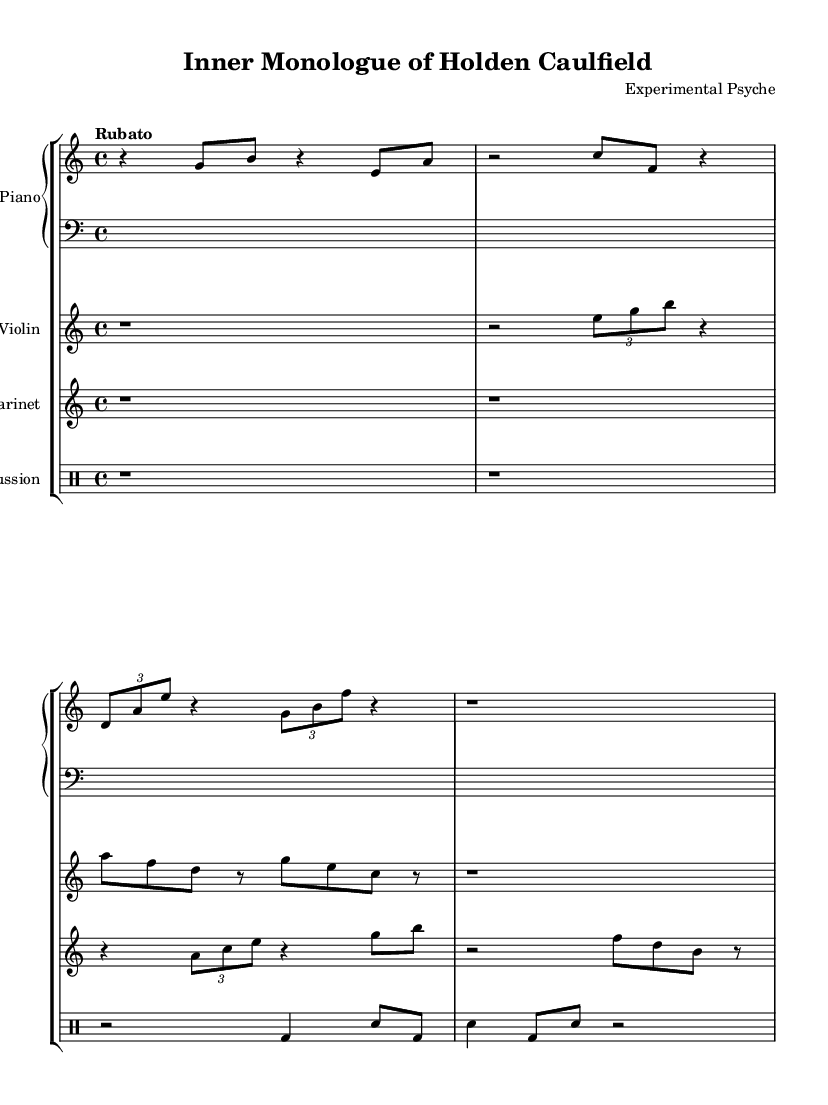What is the time signature of this music? The time signature is indicated at the beginning of the score, represented as "4/4". This means there are four beats in each measure, and the quarter note gets one beat.
Answer: 4/4 What is the tempo marking for the piece? The tempo is indicated as "Rubato", which signifies a flexible tempo. This allows the performer to stretch and compress the rhythm for expressive purposes.
Answer: Rubato What instruments are included in this composition? The instruments are listed as Piano, Violin, Clarinet, and Percussion. Each instrument has its own staff in the score, indicating they play simultaneously.
Answer: Piano, Violin, Clarinet, Percussion How many measures are present in the piano part? By counting the distinct groupings of notes and rests in the piano part, we can identify six measures in total, assuming no additional divisions are present within these measures.
Answer: 6 What is the role of the percussion in this piece? The percussion part provides rhythmic support with a pattern seen in the drum notes while also creating a contrast in sound that highlights the expressive nature of the other instruments.
Answer: Rhythmic support In which measure does the clarinet part first play a note? The clarinet part includes two full measures of rests at the beginning. The first note occurs in measure three, where a tuple of notes is played.
Answer: Measure 3 What is the primary theme conveyed through this avant-garde composition? The primary theme is an exploration of inner dialogue, specifically reflecting the psychological state of fictional characters like Holden Caulfield from "The Catcher in the Rye". This thematic exploration is illustrated through the structure and dissonance of the music.
Answer: Inner dialogue exploration 